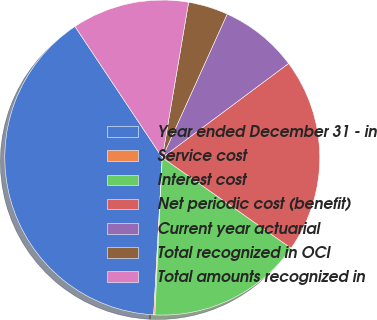Convert chart. <chart><loc_0><loc_0><loc_500><loc_500><pie_chart><fcel>Year ended December 31 - in<fcel>Service cost<fcel>Interest cost<fcel>Net periodic cost (benefit)<fcel>Current year actuarial<fcel>Total recognized in OCI<fcel>Total amounts recognized in<nl><fcel>39.79%<fcel>0.12%<fcel>15.99%<fcel>19.95%<fcel>8.05%<fcel>4.09%<fcel>12.02%<nl></chart> 